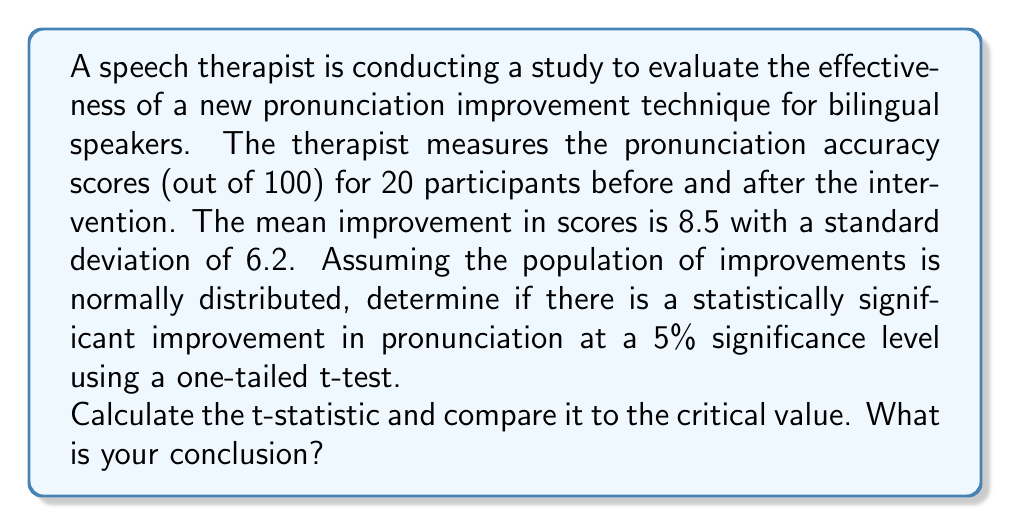Can you solve this math problem? To determine if there is a statistically significant improvement in pronunciation, we need to perform a one-tailed t-test. We'll follow these steps:

1. State the hypotheses:
   $H_0: \mu \leq 0$ (null hypothesis: no improvement or negative improvement)
   $H_a: \mu > 0$ (alternative hypothesis: positive improvement)

2. Choose the significance level:
   $\alpha = 0.05$ (given in the question)

3. Calculate the t-statistic:
   The formula for the t-statistic is:
   
   $$t = \frac{\bar{x} - \mu_0}{s / \sqrt{n}}$$
   
   Where:
   $\bar{x}$ = sample mean (8.5)
   $\mu_0$ = hypothesized population mean (0, as we're testing for improvement)
   $s$ = sample standard deviation (6.2)
   $n$ = sample size (20)

   Plugging in the values:
   
   $$t = \frac{8.5 - 0}{6.2 / \sqrt{20}} = \frac{8.5}{1.386} = 6.13$$

4. Determine the critical value:
   For a one-tailed test with $\alpha = 0.05$ and $df = n - 1 = 19$, the critical t-value is approximately 1.729 (from a t-distribution table or calculator).

5. Compare the t-statistic to the critical value:
   Our calculated t-statistic (6.13) is greater than the critical value (1.729).

6. Make a decision:
   Since the calculated t-statistic is greater than the critical value, we reject the null hypothesis.
Answer: The calculated t-statistic (6.13) is greater than the critical value (1.729), so we reject the null hypothesis. There is statistically significant evidence at the 5% level to conclude that the new pronunciation improvement technique leads to a positive improvement in pronunciation accuracy for bilingual speakers. 